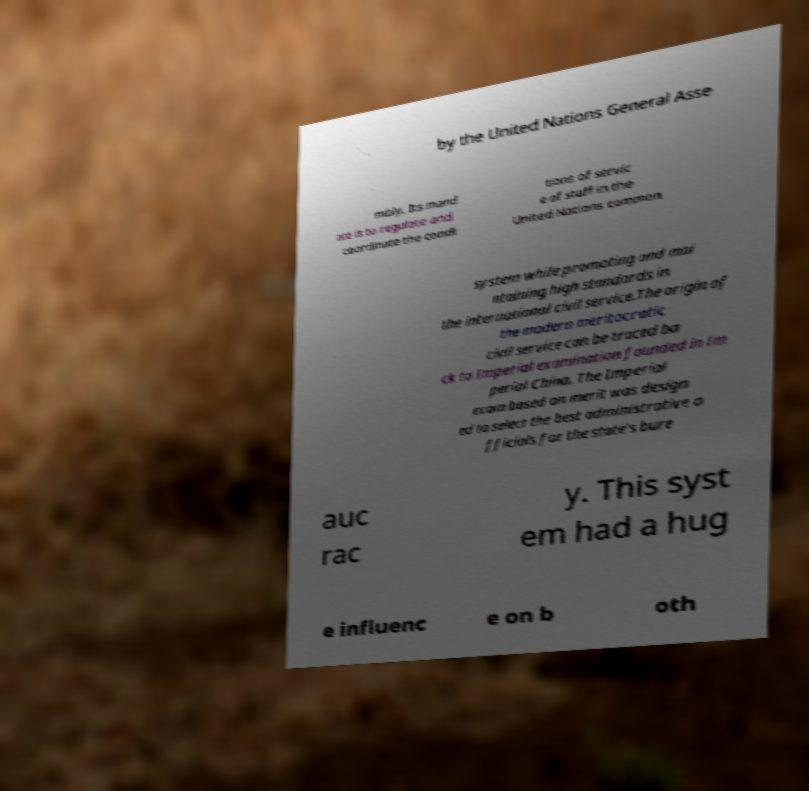Please read and relay the text visible in this image. What does it say? by the United Nations General Asse mbly. Its mand ate is to regulate and coordinate the condi tions of servic e of staff in the United Nations common system while promoting and mai ntaining high standards in the international civil service.The origin of the modern meritocratic civil service can be traced ba ck to Imperial examination founded in Im perial China. The Imperial exam based on merit was design ed to select the best administrative o fficials for the state's bure auc rac y. This syst em had a hug e influenc e on b oth 